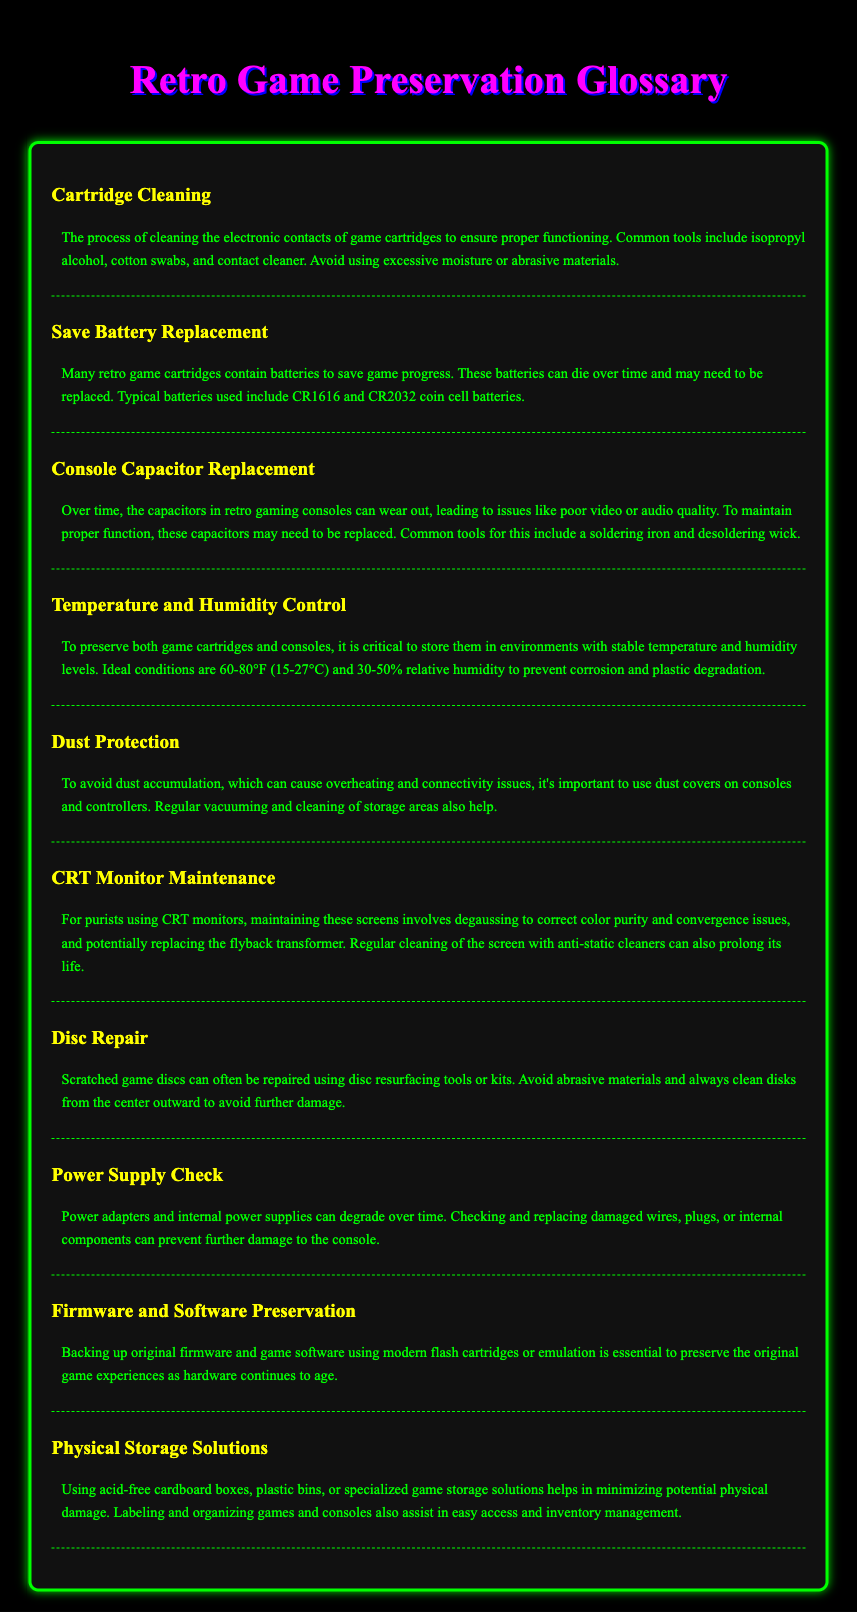What is the ideal temperature range for storage? The ideal temperature range for storing game cartridges and consoles is detailed in the Temperature and Humidity Control section.
Answer: 60-80°F What common tools are used for cartridge cleaning? The common tools for cleaning game cartridges are listed in the Cartridge Cleaning section.
Answer: Isopropyl alcohol, cotton swabs, contact cleaner Which batteries are typically used for save battery replacement? Typical batteries for save battery replacement are mentioned in the Save Battery Replacement section.
Answer: CR1616, CR2032 What is a recommended method for cleaning scratched game discs? A recommended method for repairing scratched game discs is provided in the Disc Repair section.
Answer: Disc resurfacing tools or kits What should be used to prevent dust accumulation on consoles? The recommendation for preventing dust accumulation is included in the Dust Protection section.
Answer: Dust covers Why is temperature and humidity control important? The significance of temperature and humidity control is discussed in the Temperature and Humidity Control section.
Answer: Prevent corrosion and plastic degradation What maintenance is suggested for CRT monitors? The maintenance suggestions for CRT monitors are described under CRT Monitor Maintenance.
Answer: Degaussing What type of storage solutions helps minimize physical damage to games? The suggested storage solutions to minimize physical damage are mentioned in the Physical Storage Solutions section.
Answer: Acid-free cardboard boxes What may need to be replaced in aging retro consoles? The components that may need replacement in aging retro consoles are outlined in the Console Capacitor Replacement section.
Answer: Capacitors 